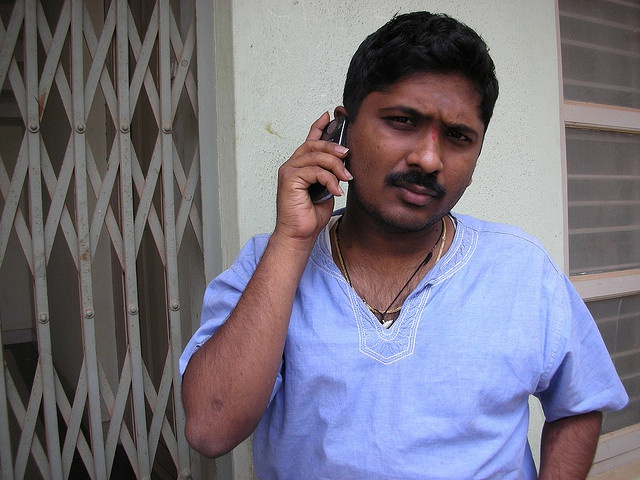Describe the objects in this image and their specific colors. I can see people in black, lightblue, brown, and lavender tones and cell phone in black and gray tones in this image. 